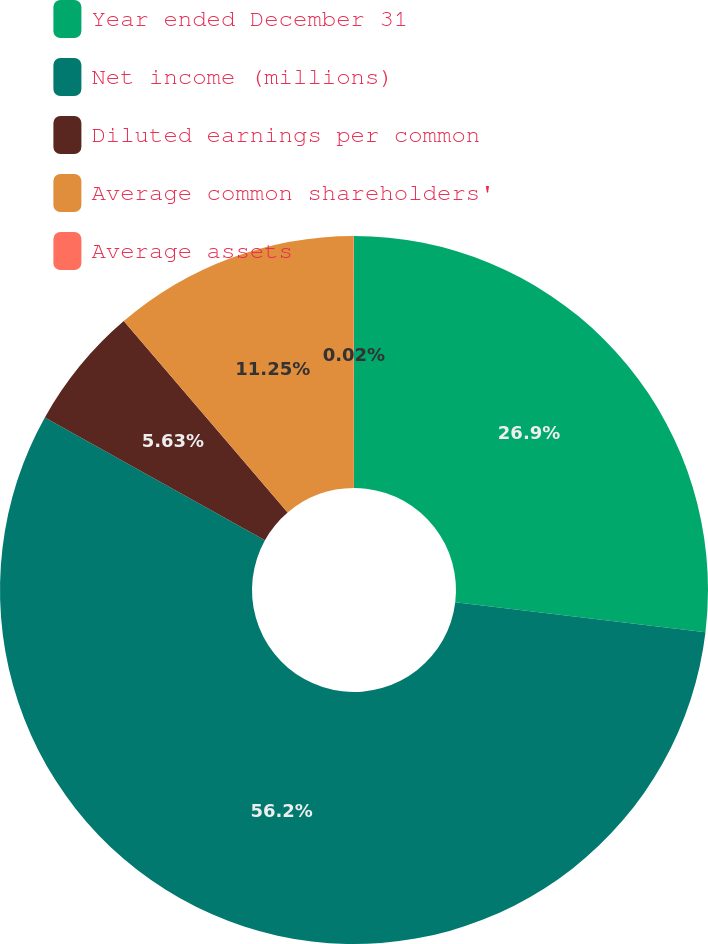<chart> <loc_0><loc_0><loc_500><loc_500><pie_chart><fcel>Year ended December 31<fcel>Net income (millions)<fcel>Diluted earnings per common<fcel>Average common shareholders'<fcel>Average assets<nl><fcel>26.9%<fcel>56.19%<fcel>5.63%<fcel>11.25%<fcel>0.02%<nl></chart> 